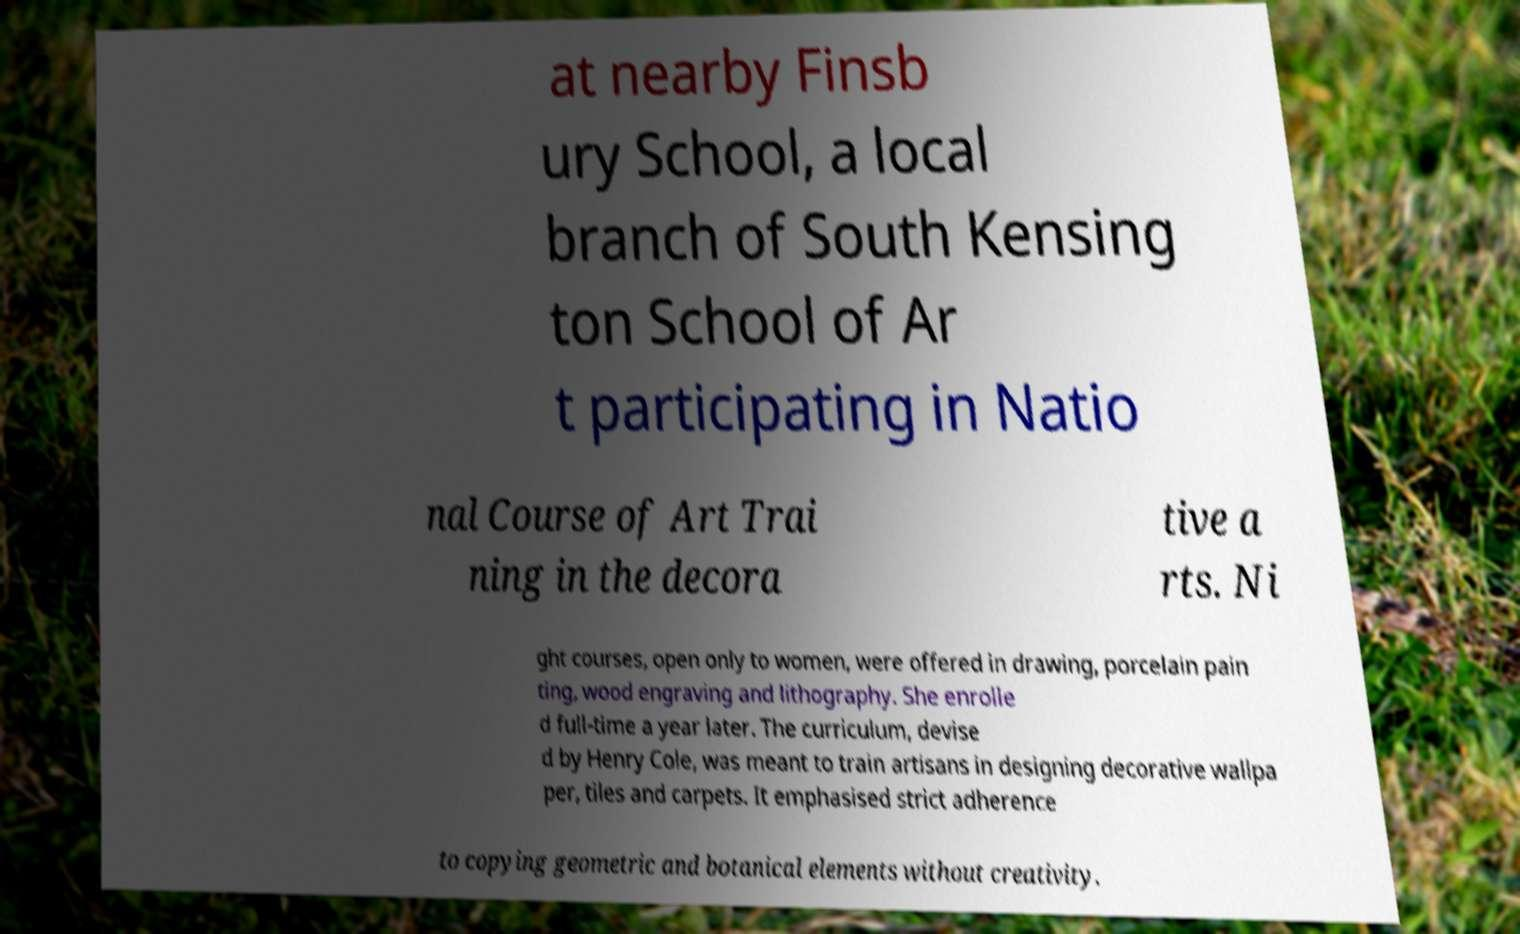Can you accurately transcribe the text from the provided image for me? at nearby Finsb ury School, a local branch of South Kensing ton School of Ar t participating in Natio nal Course of Art Trai ning in the decora tive a rts. Ni ght courses, open only to women, were offered in drawing, porcelain pain ting, wood engraving and lithography. She enrolle d full-time a year later. The curriculum, devise d by Henry Cole, was meant to train artisans in designing decorative wallpa per, tiles and carpets. It emphasised strict adherence to copying geometric and botanical elements without creativity. 